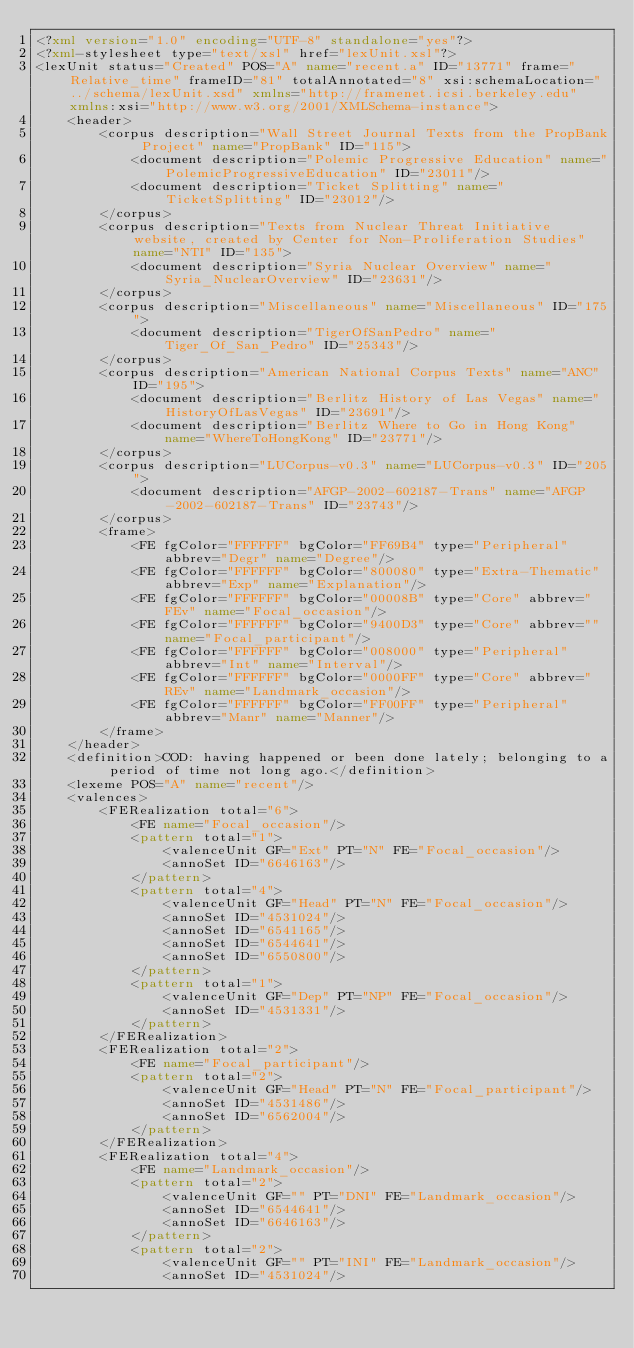Convert code to text. <code><loc_0><loc_0><loc_500><loc_500><_XML_><?xml version="1.0" encoding="UTF-8" standalone="yes"?>
<?xml-stylesheet type="text/xsl" href="lexUnit.xsl"?>
<lexUnit status="Created" POS="A" name="recent.a" ID="13771" frame="Relative_time" frameID="81" totalAnnotated="8" xsi:schemaLocation="../schema/lexUnit.xsd" xmlns="http://framenet.icsi.berkeley.edu" xmlns:xsi="http://www.w3.org/2001/XMLSchema-instance">
    <header>
        <corpus description="Wall Street Journal Texts from the PropBank Project" name="PropBank" ID="115">
            <document description="Polemic Progressive Education" name="PolemicProgressiveEducation" ID="23011"/>
            <document description="Ticket Splitting" name="TicketSplitting" ID="23012"/>
        </corpus>
        <corpus description="Texts from Nuclear Threat Initiative website, created by Center for Non-Proliferation Studies" name="NTI" ID="135">
            <document description="Syria Nuclear Overview" name="Syria_NuclearOverview" ID="23631"/>
        </corpus>
        <corpus description="Miscellaneous" name="Miscellaneous" ID="175">
            <document description="TigerOfSanPedro" name="Tiger_Of_San_Pedro" ID="25343"/>
        </corpus>
        <corpus description="American National Corpus Texts" name="ANC" ID="195">
            <document description="Berlitz History of Las Vegas" name="HistoryOfLasVegas" ID="23691"/>
            <document description="Berlitz Where to Go in Hong Kong" name="WhereToHongKong" ID="23771"/>
        </corpus>
        <corpus description="LUCorpus-v0.3" name="LUCorpus-v0.3" ID="205">
            <document description="AFGP-2002-602187-Trans" name="AFGP-2002-602187-Trans" ID="23743"/>
        </corpus>
        <frame>
            <FE fgColor="FFFFFF" bgColor="FF69B4" type="Peripheral" abbrev="Degr" name="Degree"/>
            <FE fgColor="FFFFFF" bgColor="800080" type="Extra-Thematic" abbrev="Exp" name="Explanation"/>
            <FE fgColor="FFFFFF" bgColor="00008B" type="Core" abbrev="FEv" name="Focal_occasion"/>
            <FE fgColor="FFFFFF" bgColor="9400D3" type="Core" abbrev="" name="Focal_participant"/>
            <FE fgColor="FFFFFF" bgColor="008000" type="Peripheral" abbrev="Int" name="Interval"/>
            <FE fgColor="FFFFFF" bgColor="0000FF" type="Core" abbrev="REv" name="Landmark_occasion"/>
            <FE fgColor="FFFFFF" bgColor="FF00FF" type="Peripheral" abbrev="Manr" name="Manner"/>
        </frame>
    </header>
    <definition>COD: having happened or been done lately; belonging to a period of time not long ago.</definition>
    <lexeme POS="A" name="recent"/>
    <valences>
        <FERealization total="6">
            <FE name="Focal_occasion"/>
            <pattern total="1">
                <valenceUnit GF="Ext" PT="N" FE="Focal_occasion"/>
                <annoSet ID="6646163"/>
            </pattern>
            <pattern total="4">
                <valenceUnit GF="Head" PT="N" FE="Focal_occasion"/>
                <annoSet ID="4531024"/>
                <annoSet ID="6541165"/>
                <annoSet ID="6544641"/>
                <annoSet ID="6550800"/>
            </pattern>
            <pattern total="1">
                <valenceUnit GF="Dep" PT="NP" FE="Focal_occasion"/>
                <annoSet ID="4531331"/>
            </pattern>
        </FERealization>
        <FERealization total="2">
            <FE name="Focal_participant"/>
            <pattern total="2">
                <valenceUnit GF="Head" PT="N" FE="Focal_participant"/>
                <annoSet ID="4531486"/>
                <annoSet ID="6562004"/>
            </pattern>
        </FERealization>
        <FERealization total="4">
            <FE name="Landmark_occasion"/>
            <pattern total="2">
                <valenceUnit GF="" PT="DNI" FE="Landmark_occasion"/>
                <annoSet ID="6544641"/>
                <annoSet ID="6646163"/>
            </pattern>
            <pattern total="2">
                <valenceUnit GF="" PT="INI" FE="Landmark_occasion"/>
                <annoSet ID="4531024"/></code> 